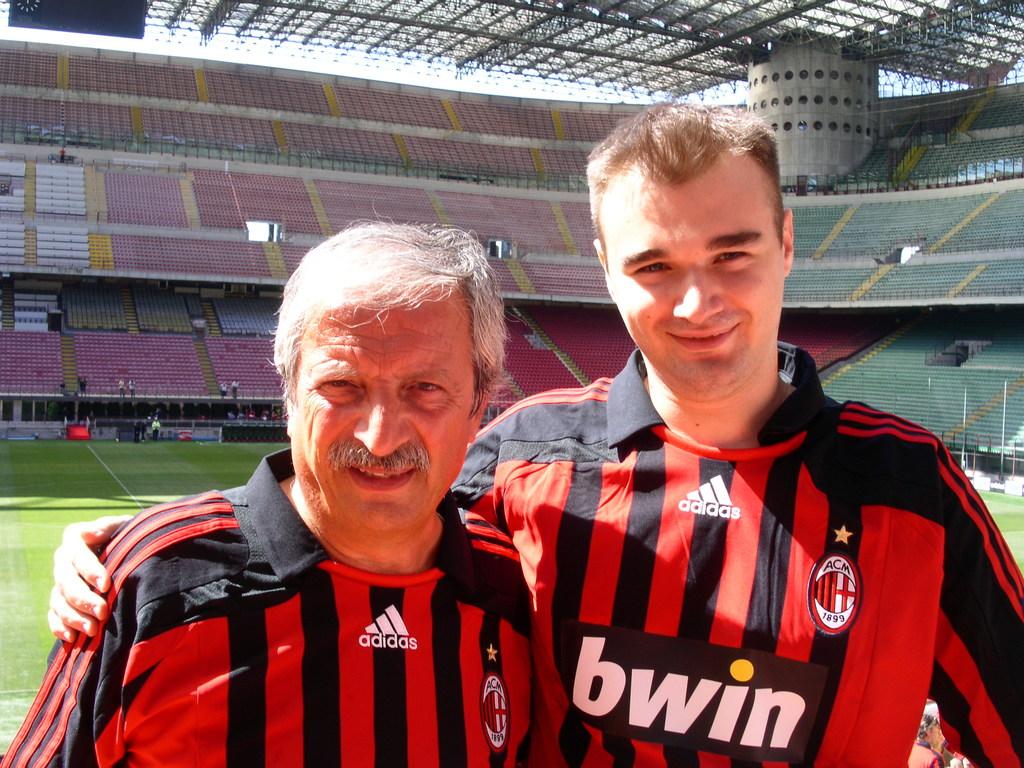What footwear brand name is on their triangular logo?
Ensure brevity in your answer.  Adidas. What name is listed on the mans shirt to the right?
Provide a short and direct response. Bwin. 